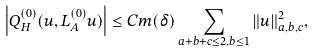Convert formula to latex. <formula><loc_0><loc_0><loc_500><loc_500>\left | Q _ { H } ^ { ( 0 ) } ( u , L _ { A } ^ { ( 0 ) } u ) \right | \leq C m ( \delta ) \sum _ { a + b + c \leq 2 , b \leq 1 } \| u \| _ { a , b , c } ^ { 2 } ,</formula> 